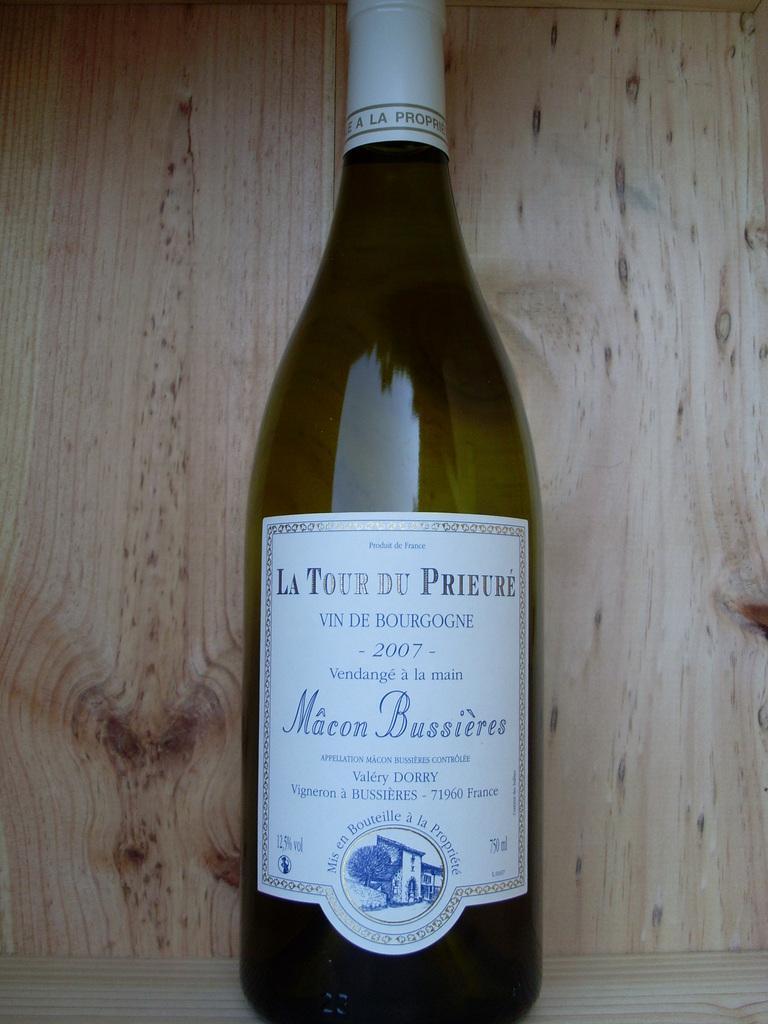Can you describe this image briefly? In this picture there is a bottle and a label on it. On the label , there is a tree and a building. There is a wooden background. 